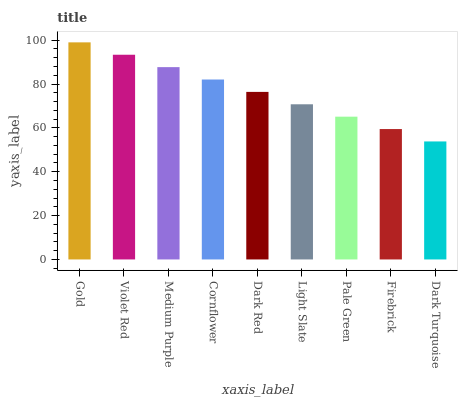Is Dark Turquoise the minimum?
Answer yes or no. Yes. Is Gold the maximum?
Answer yes or no. Yes. Is Violet Red the minimum?
Answer yes or no. No. Is Violet Red the maximum?
Answer yes or no. No. Is Gold greater than Violet Red?
Answer yes or no. Yes. Is Violet Red less than Gold?
Answer yes or no. Yes. Is Violet Red greater than Gold?
Answer yes or no. No. Is Gold less than Violet Red?
Answer yes or no. No. Is Dark Red the high median?
Answer yes or no. Yes. Is Dark Red the low median?
Answer yes or no. Yes. Is Light Slate the high median?
Answer yes or no. No. Is Medium Purple the low median?
Answer yes or no. No. 